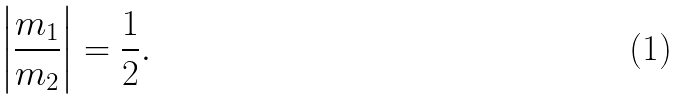Convert formula to latex. <formula><loc_0><loc_0><loc_500><loc_500>\left | \frac { m _ { 1 } } { m _ { 2 } } \right | = \frac { 1 } { 2 } .</formula> 